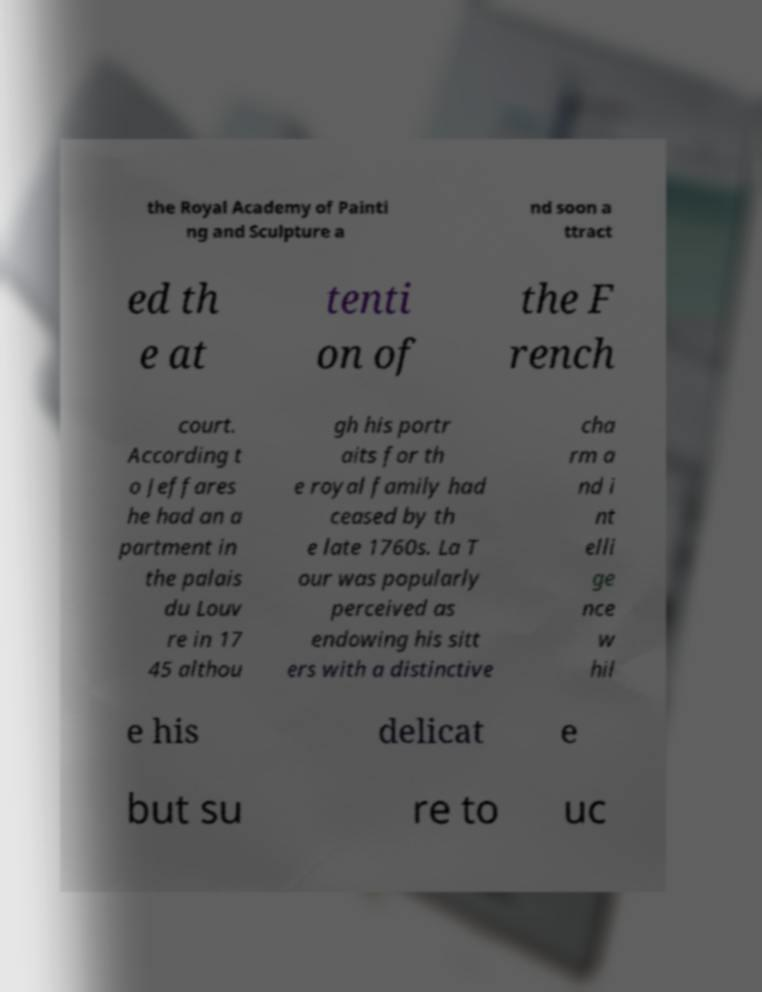Can you accurately transcribe the text from the provided image for me? the Royal Academy of Painti ng and Sculpture a nd soon a ttract ed th e at tenti on of the F rench court. According t o Jeffares he had an a partment in the palais du Louv re in 17 45 althou gh his portr aits for th e royal family had ceased by th e late 1760s. La T our was popularly perceived as endowing his sitt ers with a distinctive cha rm a nd i nt elli ge nce w hil e his delicat e but su re to uc 